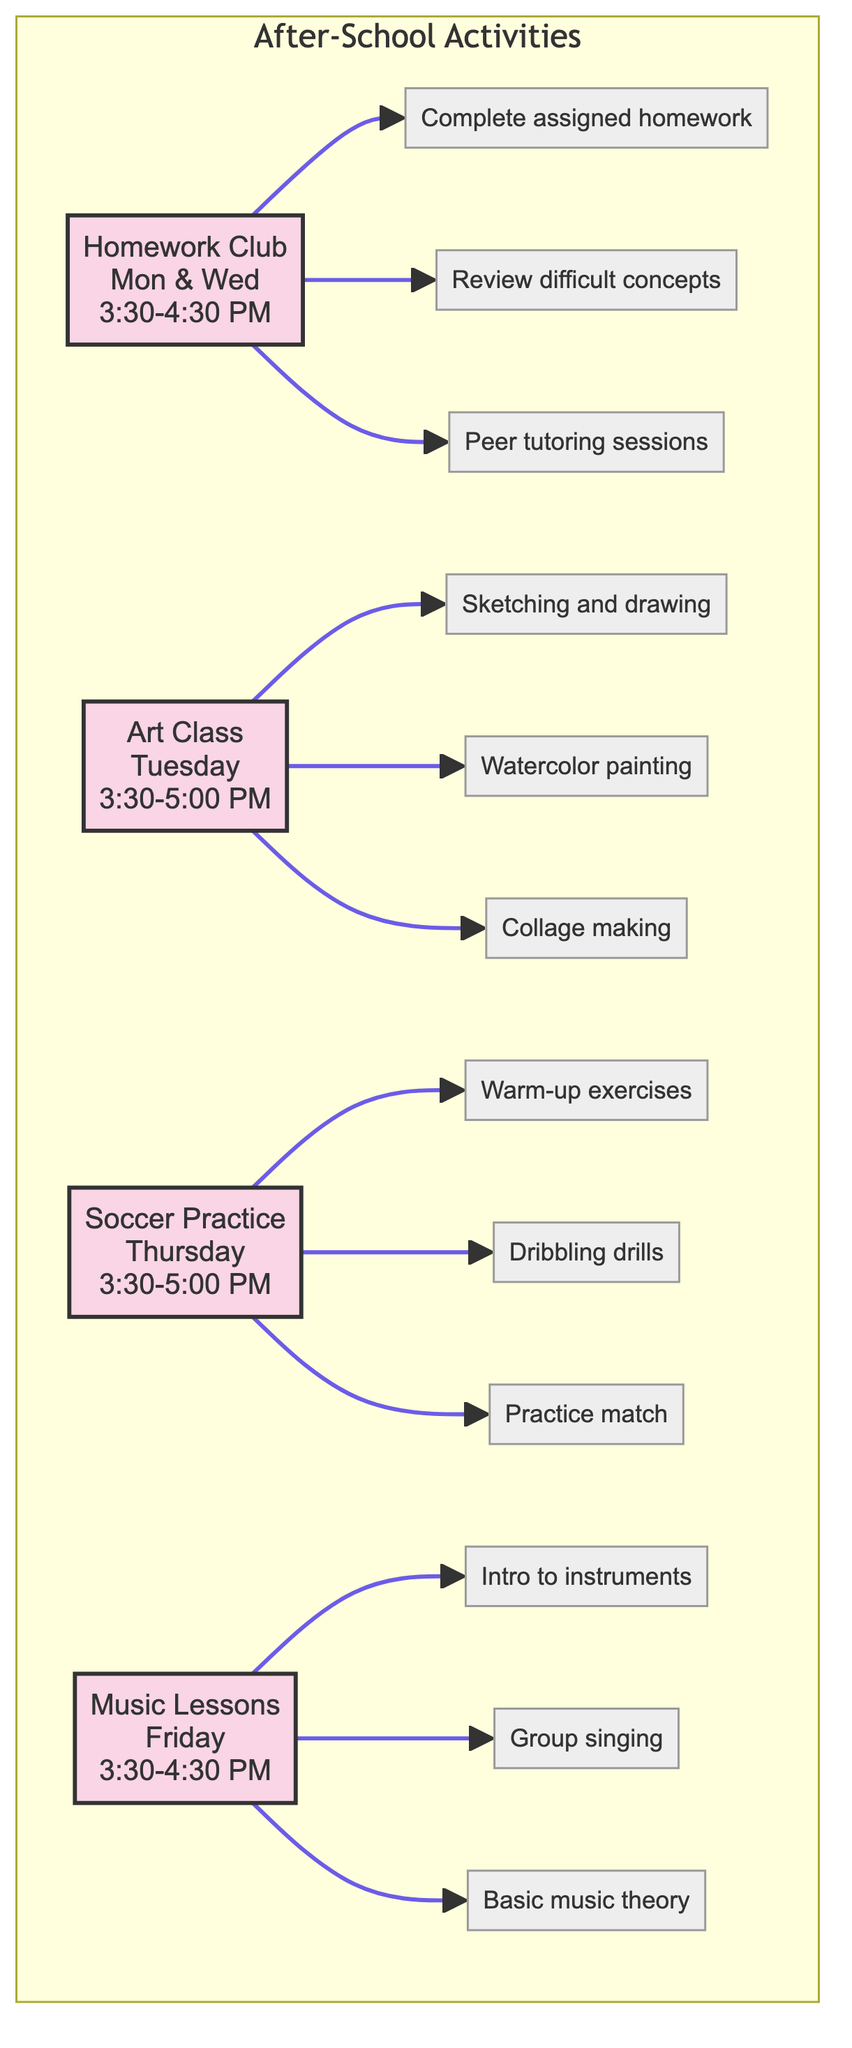What activities are held on Monday? According to the diagram, the activities listed for Monday are connected to the Homework Club. Therefore, the only activity on that day is Homework Club.
Answer: Homework Club How many tasks are associated with Art Class? The Art Class node connects to three specific tasks: Sketching and drawing exercises, Painting with watercolors, and Creative project: making a collage. Thus, there are three tasks associated with Art Class.
Answer: 3 What time does Soccer Practice start? Looking at the Soccer Practice node, it indicates that this activity takes place from 3:30 PM to 5:00 PM. Therefore, the starting time is 3:30 PM.
Answer: 3:30 PM Which activity is dedicated to music? By inspecting the nodes in the diagram, Music Lessons is identified as the activity specifically designated for music-related tasks such as Intro to musical instruments and Group singing practice.
Answer: Music Lessons What is one task that involves painting? Under the Art Class node, one of the tasks listed is Painting with watercolors, indicating that this task involves painting activities.
Answer: Painting with watercolors How many days does Homework Club meet? The Homework Club is indicated to occur on Monday and Wednesday. Therefore, it meets on two days of the week.
Answer: 2 What type of exercise is part of Soccer Practice? Referring to the tasks under the Soccer Practice node, Warm-up exercises and Dribbling drills are specifically mentioned as types of exercises involved in this activity. Therefore, the answer relates to exercises.
Answer: Warm-up exercises Which activity takes place on Fridays? The diagram specifies that Music Lessons is the activity scheduled for Fridays, during which various music-related tasks are conducted.
Answer: Music Lessons What is the duration of Art Class? The Art Class node indicates that this activity runs from 3:30 PM to 5:00 PM, which totals a duration of one hour and thirty minutes.
Answer: 1 hour 30 minutes 